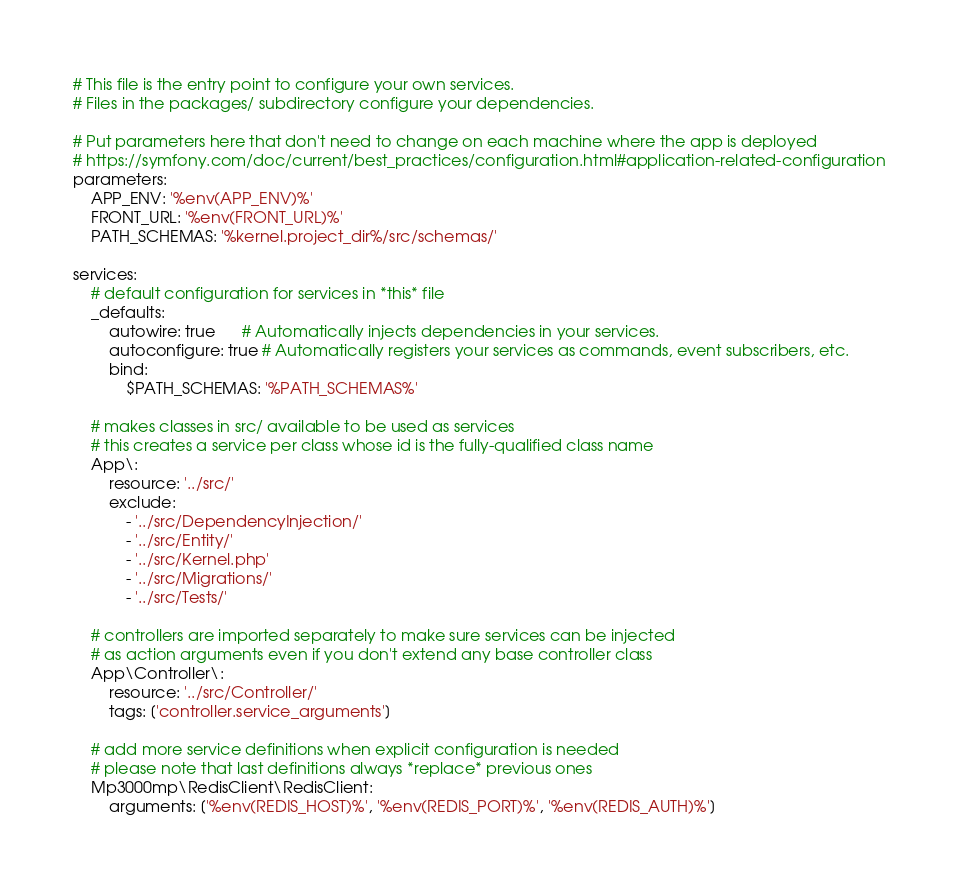Convert code to text. <code><loc_0><loc_0><loc_500><loc_500><_YAML_># This file is the entry point to configure your own services.
# Files in the packages/ subdirectory configure your dependencies.

# Put parameters here that don't need to change on each machine where the app is deployed
# https://symfony.com/doc/current/best_practices/configuration.html#application-related-configuration
parameters:
    APP_ENV: '%env(APP_ENV)%'
    FRONT_URL: '%env(FRONT_URL)%'
    PATH_SCHEMAS: '%kernel.project_dir%/src/schemas/'

services:
    # default configuration for services in *this* file
    _defaults:
        autowire: true      # Automatically injects dependencies in your services.
        autoconfigure: true # Automatically registers your services as commands, event subscribers, etc.
        bind:
            $PATH_SCHEMAS: '%PATH_SCHEMAS%'

    # makes classes in src/ available to be used as services
    # this creates a service per class whose id is the fully-qualified class name
    App\:
        resource: '../src/'
        exclude:
            - '../src/DependencyInjection/'
            - '../src/Entity/'
            - '../src/Kernel.php'
            - '../src/Migrations/'
            - '../src/Tests/'

    # controllers are imported separately to make sure services can be injected
    # as action arguments even if you don't extend any base controller class
    App\Controller\:
        resource: '../src/Controller/'
        tags: ['controller.service_arguments']

    # add more service definitions when explicit configuration is needed
    # please note that last definitions always *replace* previous ones
    Mp3000mp\RedisClient\RedisClient:
        arguments: ['%env(REDIS_HOST)%', '%env(REDIS_PORT)%', '%env(REDIS_AUTH)%']
</code> 